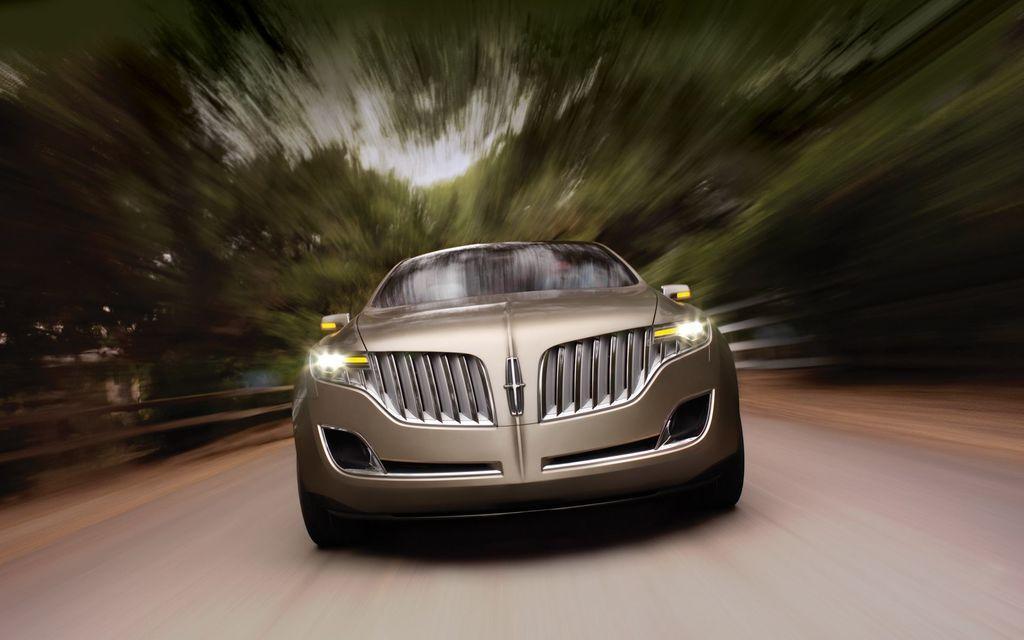In one or two sentences, can you explain what this image depicts? In this we can see a car on the road. In the background, we can see greenery. 